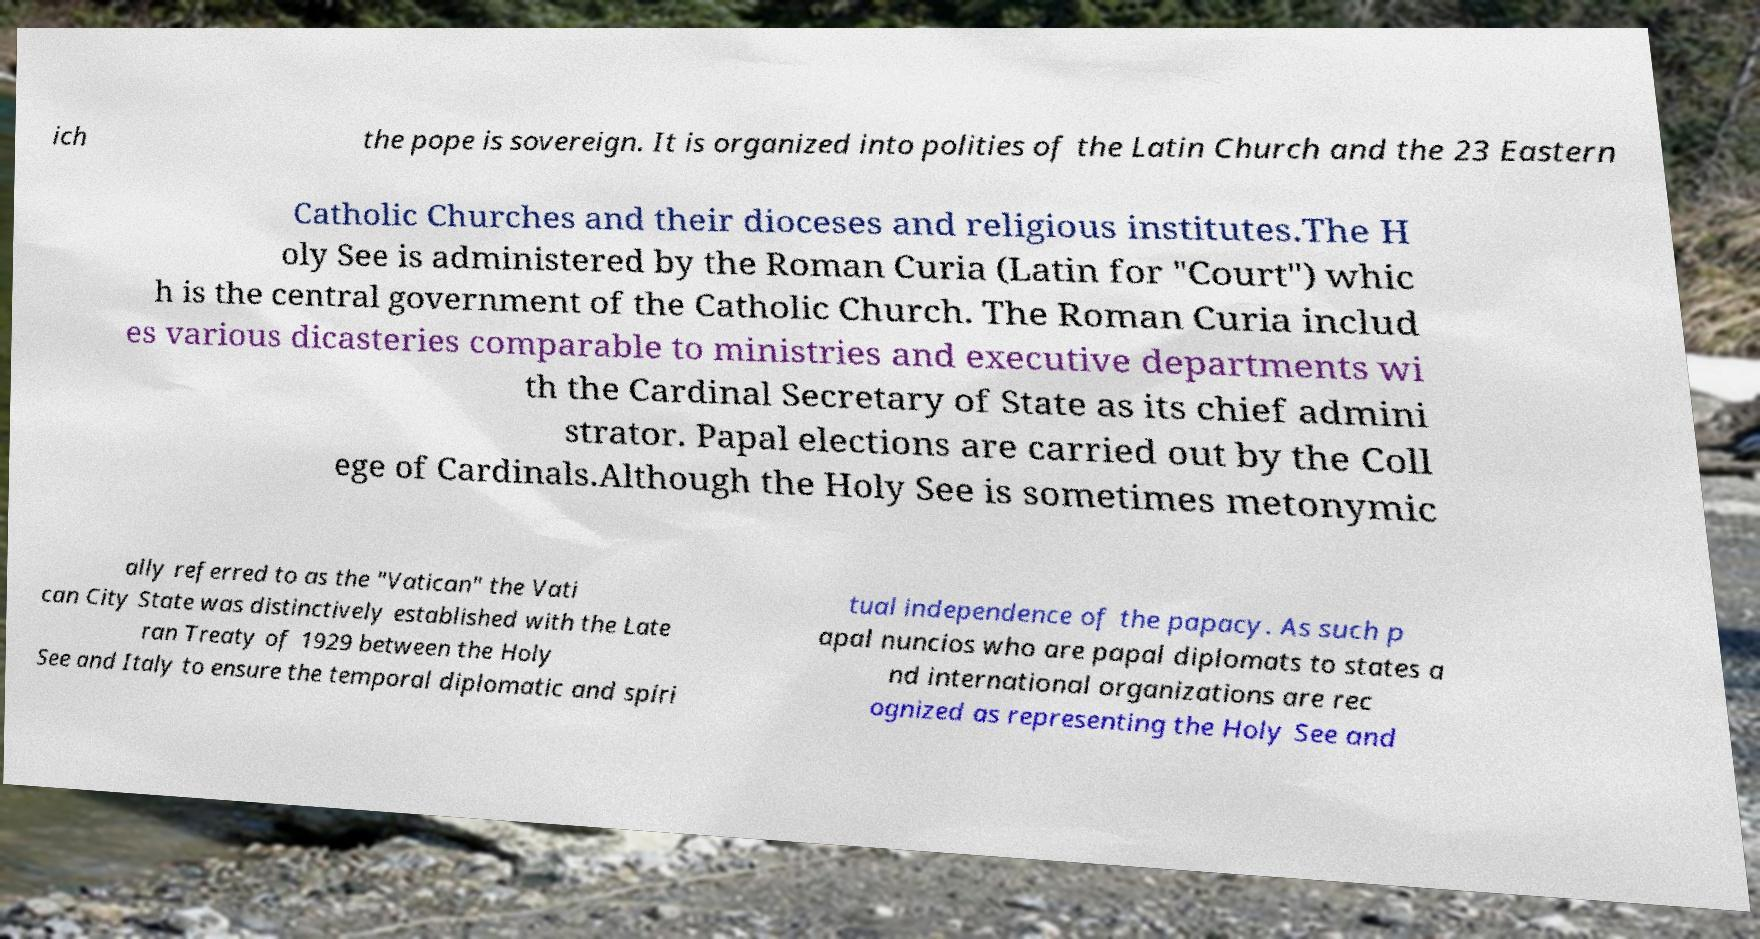For documentation purposes, I need the text within this image transcribed. Could you provide that? ich the pope is sovereign. It is organized into polities of the Latin Church and the 23 Eastern Catholic Churches and their dioceses and religious institutes.The H oly See is administered by the Roman Curia (Latin for "Court") whic h is the central government of the Catholic Church. The Roman Curia includ es various dicasteries comparable to ministries and executive departments wi th the Cardinal Secretary of State as its chief admini strator. Papal elections are carried out by the Coll ege of Cardinals.Although the Holy See is sometimes metonymic ally referred to as the "Vatican" the Vati can City State was distinctively established with the Late ran Treaty of 1929 between the Holy See and Italy to ensure the temporal diplomatic and spiri tual independence of the papacy. As such p apal nuncios who are papal diplomats to states a nd international organizations are rec ognized as representing the Holy See and 